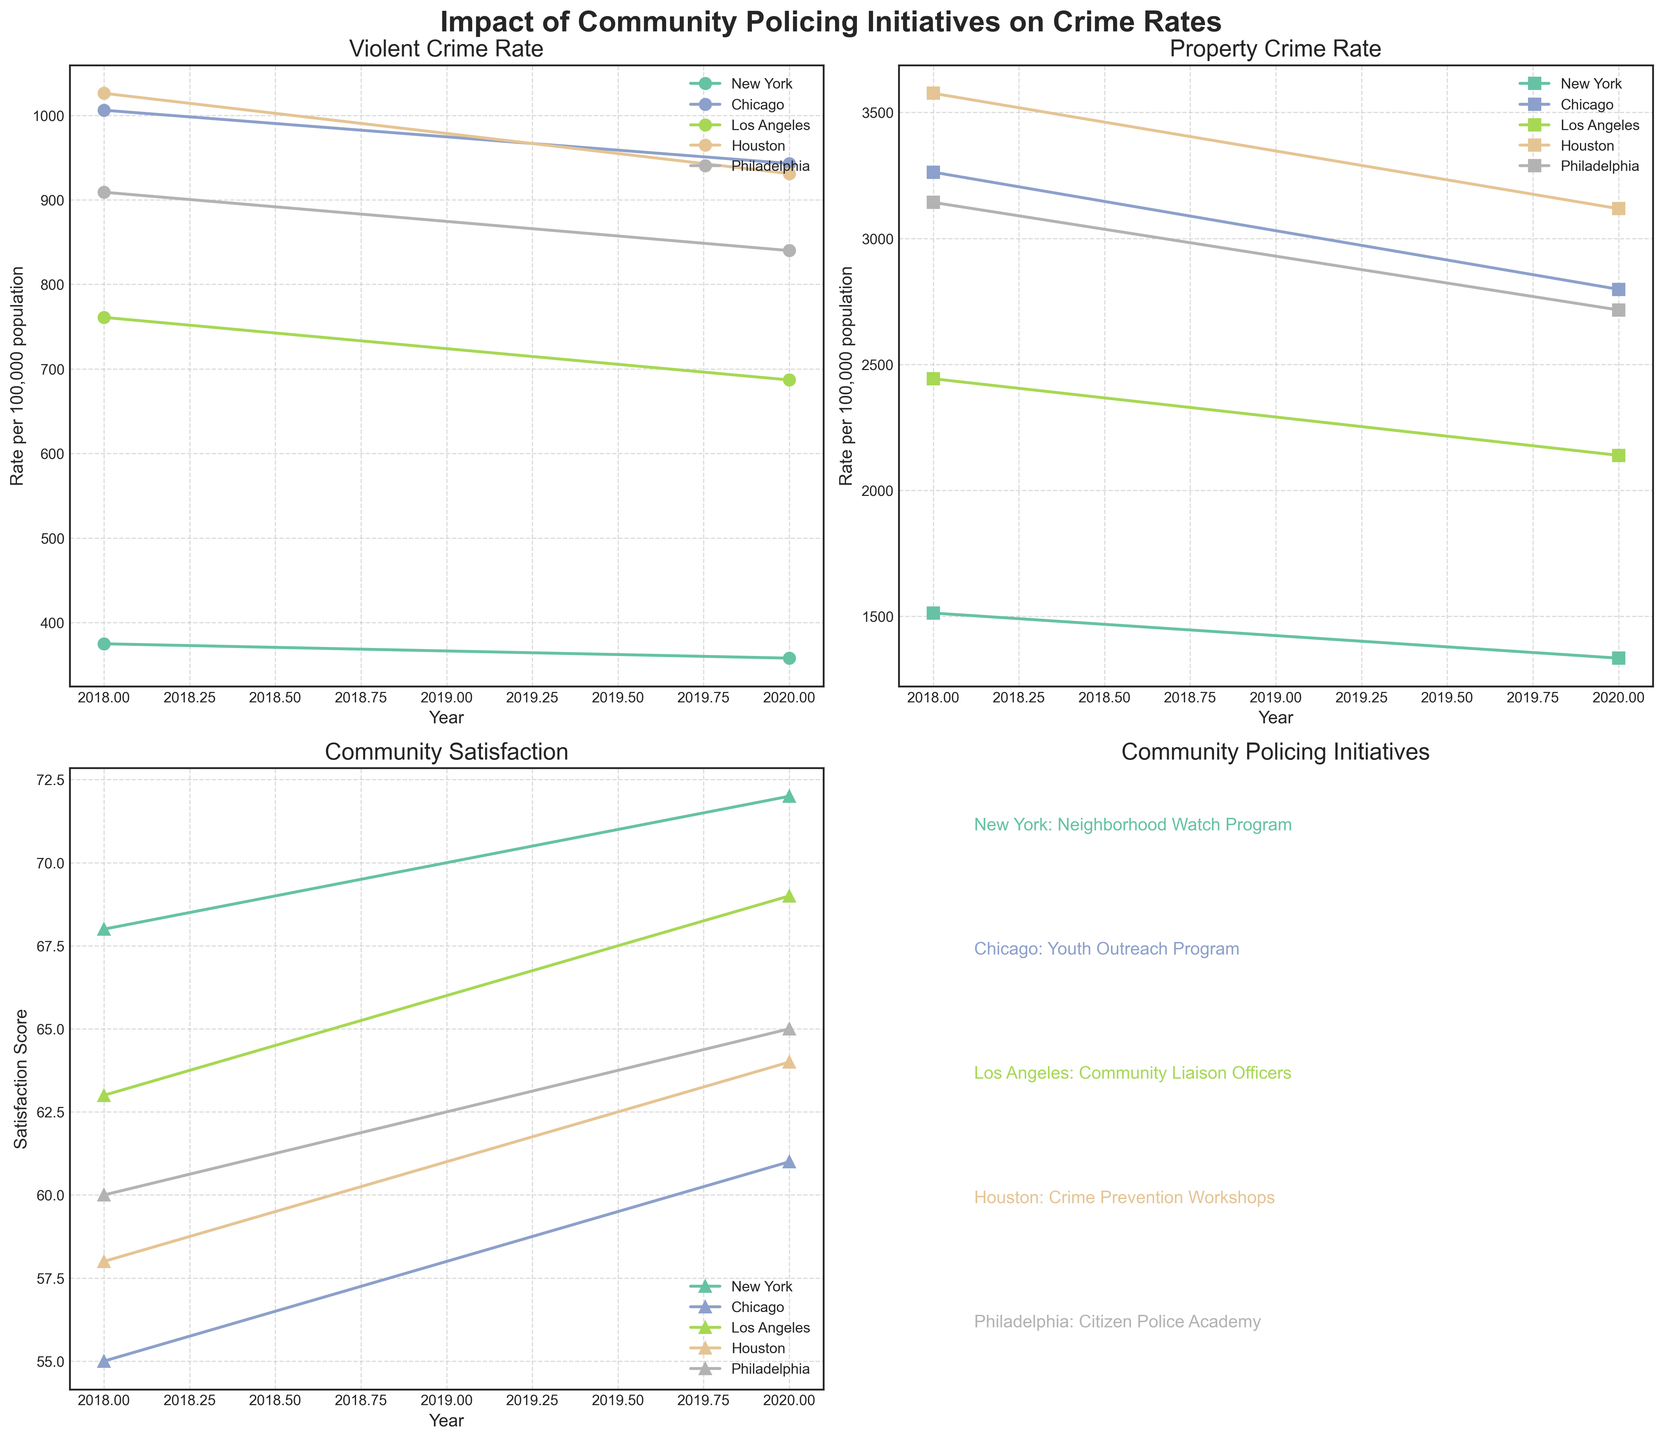What is the overall trend in the Violent Crime Rate for New York from 2018 to 2020? The plot for the Violent Crime Rate shows that New York's rate decreased from 375 in 2018 to 358 in 2020.
Answer: Decreasing What city had the highest Property Crime Rate in 2018? The Property Crime Rate subplot shows that Houston had the highest rate at 3576 in 2018.
Answer: Houston Which city saw the biggest improvement in Community Satisfaction from 2018 to 2020? The Community Satisfaction subplot indicates that Philadelphia improved from 60 to 65, a change of 5 points, which is the largest increase among the cities.
Answer: Philadelphia Comparing the Violent Crime Rates, did Los Angeles or Houston see a greater reduction from 2018 to 2020? Los Angeles' Violent Crime Rate decreased from 761 to 687 (a reduction of 74), while Houston's decreased from 1026 to 931 (a reduction of 95). Hence, Houston saw a greater reduction.
Answer: Houston How does the Property Crime Rate in Chicago compare between 2018 and 2020? The Property Crime Rate in Chicago reduced from 3263 in 2018 to 2798 in 2020.
Answer: Reduced What is the relationship between the Community Satisfaction and the Violent Crime Rate in New York from 2018 to 2020? As the Violent Crime Rate in New York decreased from 375 to 358, the Community Satisfaction increased from 68 to 72.
Answer: Inverse relationship Which city had the lowest Violent Crime Rate in 2020? According to the Violent Crime Rate subplot, New York had the lowest rate at 358 in 2020.
Answer: New York Between which years was the most significant decrease in Property Crime Rate observed in Philadelphia? The Property Crime Rate in Philadelphia decreased from 3143 in 2018 to 2716 in 2020, from 2018 to 2020.
Answer: 2018 to 2020 What initiative does Los Angeles use for community policing according to the figure? The subplot for community policing initiatives states that Los Angeles uses "Community Liaison Officers."
Answer: Community Liaison Officers How did the Community Satisfaction change in Houston from 2018 to 2020? The Community Satisfaction in Houston increased from 58 in 2018 to 64 in 2020.
Answer: Increased 